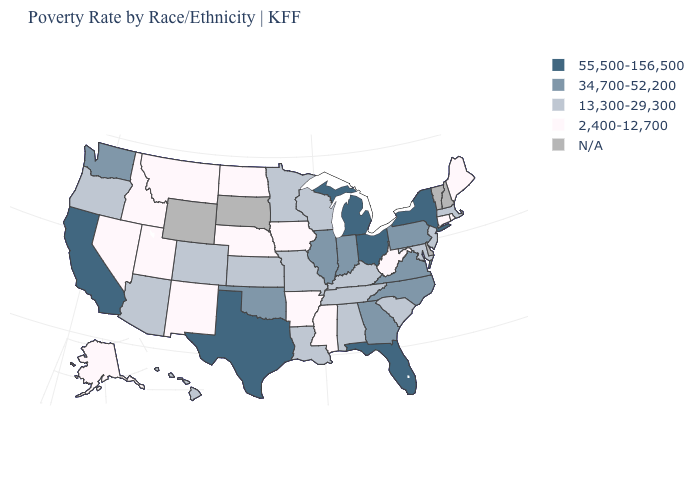Name the states that have a value in the range 13,300-29,300?
Short answer required. Alabama, Arizona, Colorado, Hawaii, Kansas, Kentucky, Louisiana, Maryland, Massachusetts, Minnesota, Missouri, New Jersey, Oregon, South Carolina, Tennessee, Wisconsin. Name the states that have a value in the range 13,300-29,300?
Short answer required. Alabama, Arizona, Colorado, Hawaii, Kansas, Kentucky, Louisiana, Maryland, Massachusetts, Minnesota, Missouri, New Jersey, Oregon, South Carolina, Tennessee, Wisconsin. Is the legend a continuous bar?
Short answer required. No. Among the states that border Utah , which have the highest value?
Write a very short answer. Arizona, Colorado. Name the states that have a value in the range 13,300-29,300?
Write a very short answer. Alabama, Arizona, Colorado, Hawaii, Kansas, Kentucky, Louisiana, Maryland, Massachusetts, Minnesota, Missouri, New Jersey, Oregon, South Carolina, Tennessee, Wisconsin. What is the value of Kentucky?
Answer briefly. 13,300-29,300. What is the highest value in the USA?
Write a very short answer. 55,500-156,500. Name the states that have a value in the range 13,300-29,300?
Short answer required. Alabama, Arizona, Colorado, Hawaii, Kansas, Kentucky, Louisiana, Maryland, Massachusetts, Minnesota, Missouri, New Jersey, Oregon, South Carolina, Tennessee, Wisconsin. Which states have the lowest value in the USA?
Answer briefly. Alaska, Arkansas, Connecticut, Idaho, Iowa, Maine, Mississippi, Montana, Nebraska, Nevada, New Mexico, North Dakota, Rhode Island, Utah, West Virginia. Name the states that have a value in the range 34,700-52,200?
Write a very short answer. Georgia, Illinois, Indiana, North Carolina, Oklahoma, Pennsylvania, Virginia, Washington. What is the value of Tennessee?
Quick response, please. 13,300-29,300. What is the value of North Dakota?
Write a very short answer. 2,400-12,700. Among the states that border Maryland , which have the highest value?
Answer briefly. Pennsylvania, Virginia. Does Nebraska have the lowest value in the MidWest?
Quick response, please. Yes. 